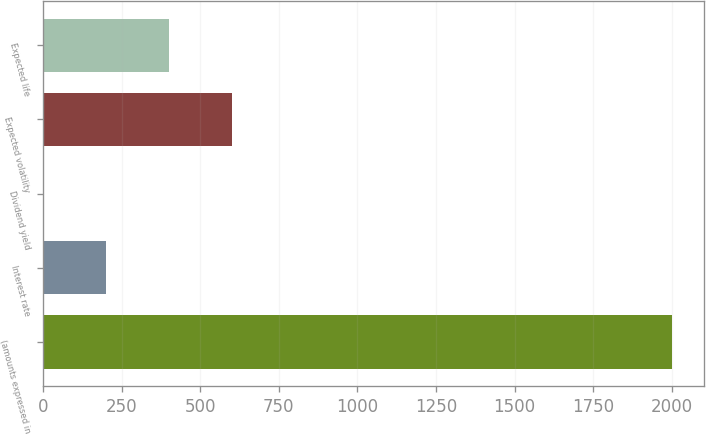Convert chart. <chart><loc_0><loc_0><loc_500><loc_500><bar_chart><fcel>(amounts expressed in<fcel>Interest rate<fcel>Dividend yield<fcel>Expected volatility<fcel>Expected life<nl><fcel>2002<fcel>200.59<fcel>0.43<fcel>600.91<fcel>400.75<nl></chart> 